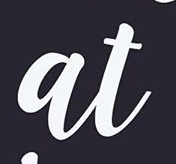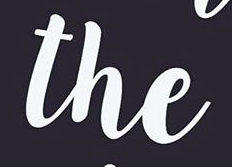Transcribe the words shown in these images in order, separated by a semicolon. at; the 